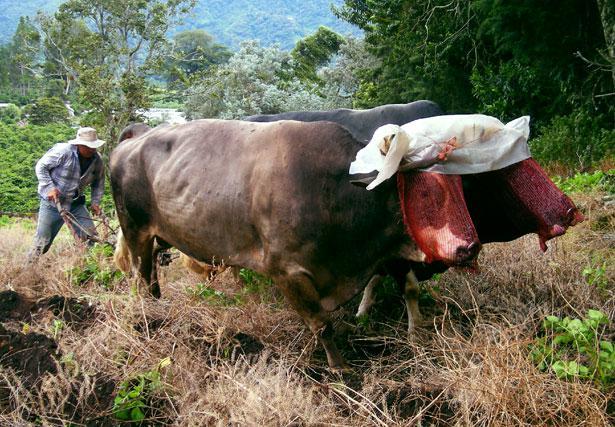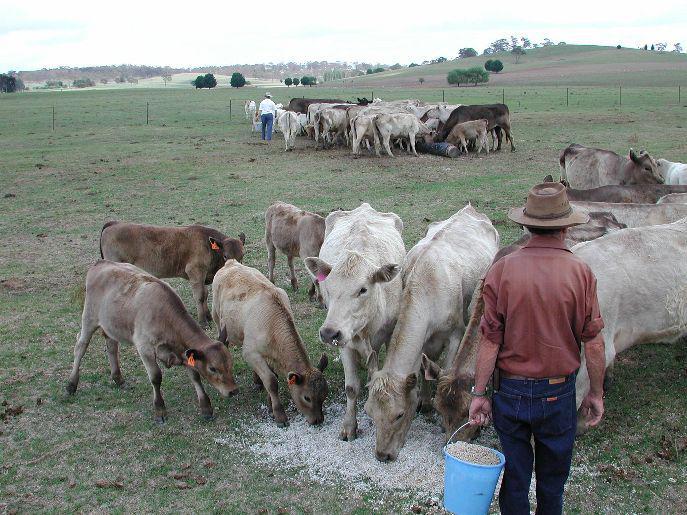The first image is the image on the left, the second image is the image on the right. Examine the images to the left and right. Is the description "An image shows all brown oxen hitched to a green covered wagon with red wheels and aimed rightward." accurate? Answer yes or no. No. 